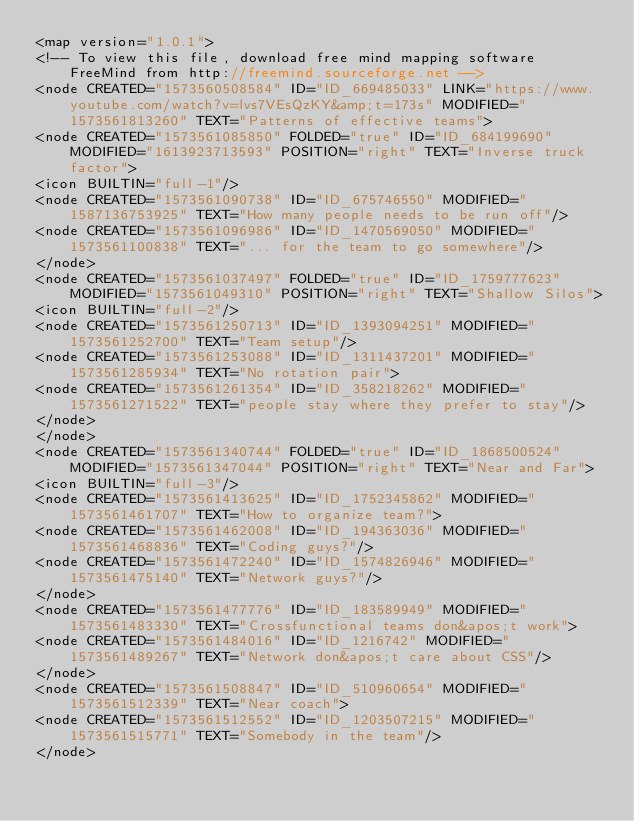Convert code to text. <code><loc_0><loc_0><loc_500><loc_500><_ObjectiveC_><map version="1.0.1">
<!-- To view this file, download free mind mapping software FreeMind from http://freemind.sourceforge.net -->
<node CREATED="1573560508584" ID="ID_669485033" LINK="https://www.youtube.com/watch?v=lvs7VEsQzKY&amp;t=173s" MODIFIED="1573561813260" TEXT="Patterns of effective teams">
<node CREATED="1573561085850" FOLDED="true" ID="ID_684199690" MODIFIED="1613923713593" POSITION="right" TEXT="Inverse truck factor">
<icon BUILTIN="full-1"/>
<node CREATED="1573561090738" ID="ID_675746550" MODIFIED="1587136753925" TEXT="How many people needs to be run off"/>
<node CREATED="1573561096986" ID="ID_1470569050" MODIFIED="1573561100838" TEXT="... for the team to go somewhere"/>
</node>
<node CREATED="1573561037497" FOLDED="true" ID="ID_1759777623" MODIFIED="1573561049310" POSITION="right" TEXT="Shallow Silos">
<icon BUILTIN="full-2"/>
<node CREATED="1573561250713" ID="ID_1393094251" MODIFIED="1573561252700" TEXT="Team setup"/>
<node CREATED="1573561253088" ID="ID_1311437201" MODIFIED="1573561285934" TEXT="No rotation pair">
<node CREATED="1573561261354" ID="ID_358218262" MODIFIED="1573561271522" TEXT="people stay where they prefer to stay"/>
</node>
</node>
<node CREATED="1573561340744" FOLDED="true" ID="ID_1868500524" MODIFIED="1573561347044" POSITION="right" TEXT="Near and Far">
<icon BUILTIN="full-3"/>
<node CREATED="1573561413625" ID="ID_1752345862" MODIFIED="1573561461707" TEXT="How to organize team?">
<node CREATED="1573561462008" ID="ID_194363036" MODIFIED="1573561468836" TEXT="Coding guys?"/>
<node CREATED="1573561472240" ID="ID_1574826946" MODIFIED="1573561475140" TEXT="Network guys?"/>
</node>
<node CREATED="1573561477776" ID="ID_183589949" MODIFIED="1573561483330" TEXT="Crossfunctional teams don&apos;t work">
<node CREATED="1573561484016" ID="ID_1216742" MODIFIED="1573561489267" TEXT="Network don&apos;t care about CSS"/>
</node>
<node CREATED="1573561508847" ID="ID_510960654" MODIFIED="1573561512339" TEXT="Near coach">
<node CREATED="1573561512552" ID="ID_1203507215" MODIFIED="1573561515771" TEXT="Somebody in the team"/>
</node></code> 